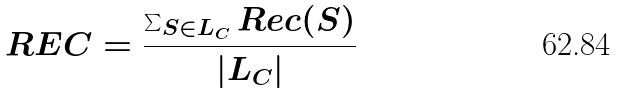Convert formula to latex. <formula><loc_0><loc_0><loc_500><loc_500>R E C = \frac { \sum _ { S \in L _ { C } } R e c ( S ) } { | L _ { C } | }</formula> 